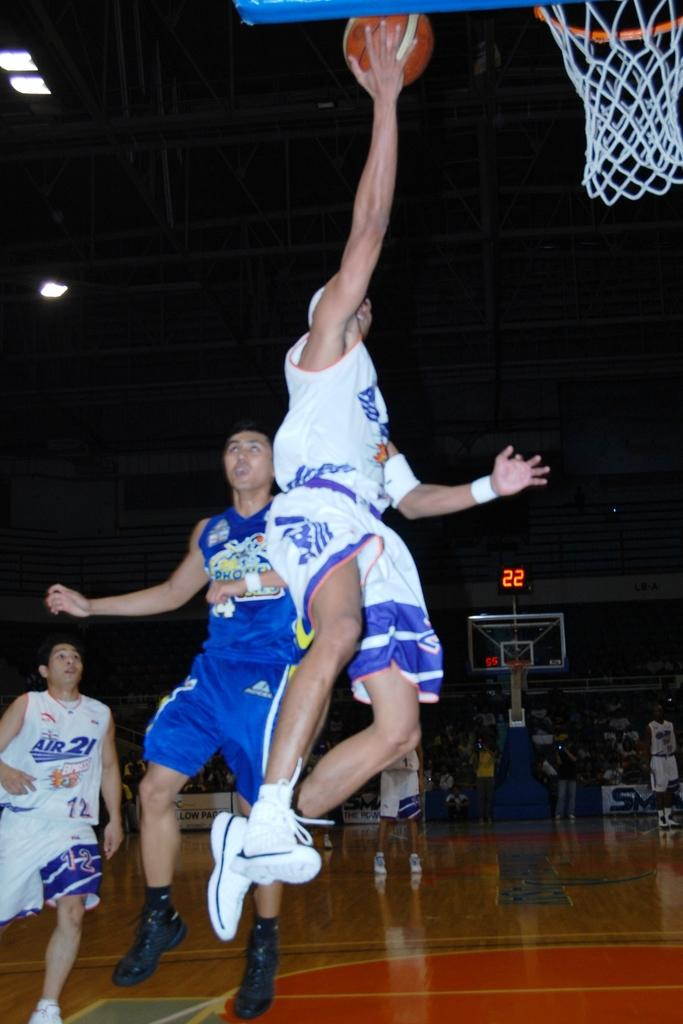<image>
Summarize the visual content of the image. A basketball player is jumping to dump a ball while one player wearing an shirt with air 21 written in front. 